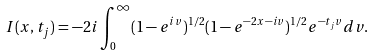<formula> <loc_0><loc_0><loc_500><loc_500>I ( x , t _ { j } ) = - 2 i \int _ { 0 } ^ { \infty } ( 1 - e ^ { i v } ) ^ { 1 / 2 } ( 1 - e ^ { - 2 x - i v } ) ^ { 1 / 2 } e ^ { - t _ { j } v } d v .</formula> 